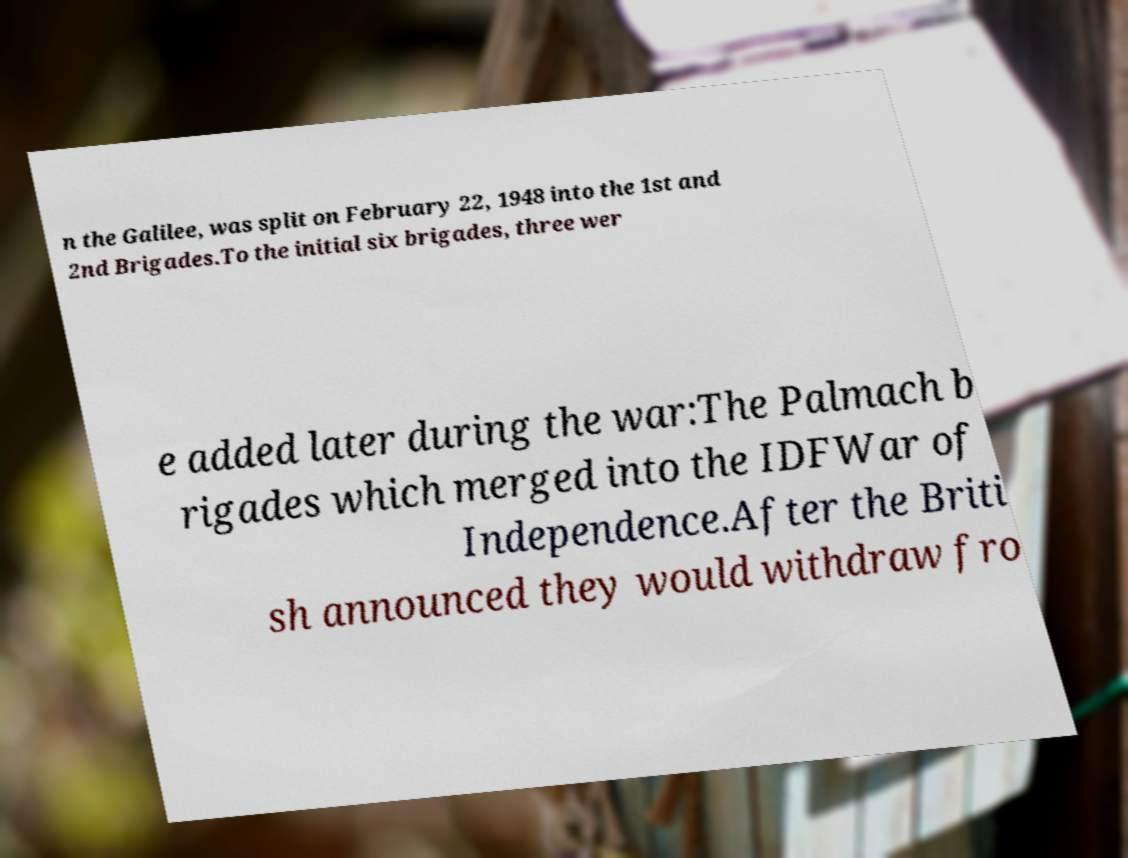Can you read and provide the text displayed in the image?This photo seems to have some interesting text. Can you extract and type it out for me? n the Galilee, was split on February 22, 1948 into the 1st and 2nd Brigades.To the initial six brigades, three wer e added later during the war:The Palmach b rigades which merged into the IDFWar of Independence.After the Briti sh announced they would withdraw fro 